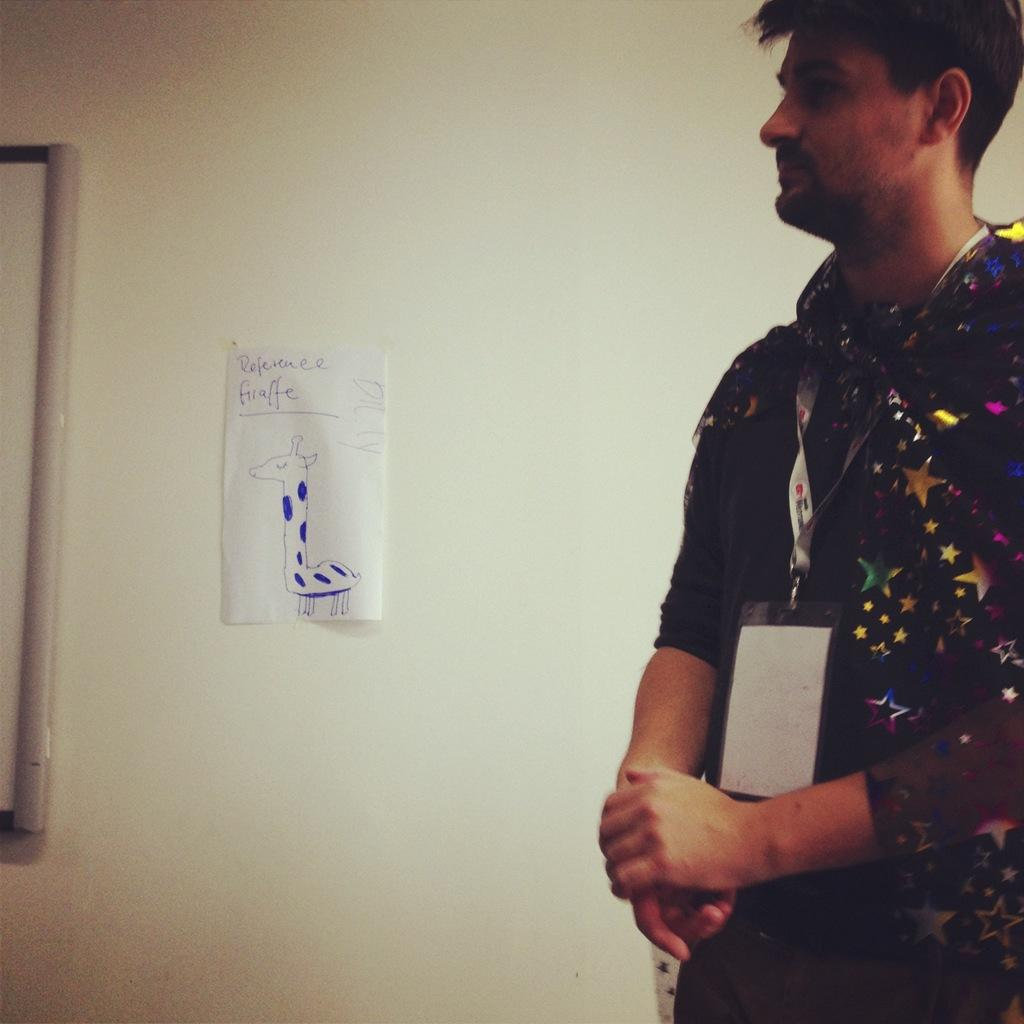What is located on the right side of the image? There is a man on the right side of the image. What is the man wearing in the image? The man is wearing a tag in the image. What can be seen on the wall beside the man? There is a paper on the wall beside the man. How many icicles are hanging from the man's tag in the image? There are no icicles present in the image, as it is not a cold environment or winter season. 